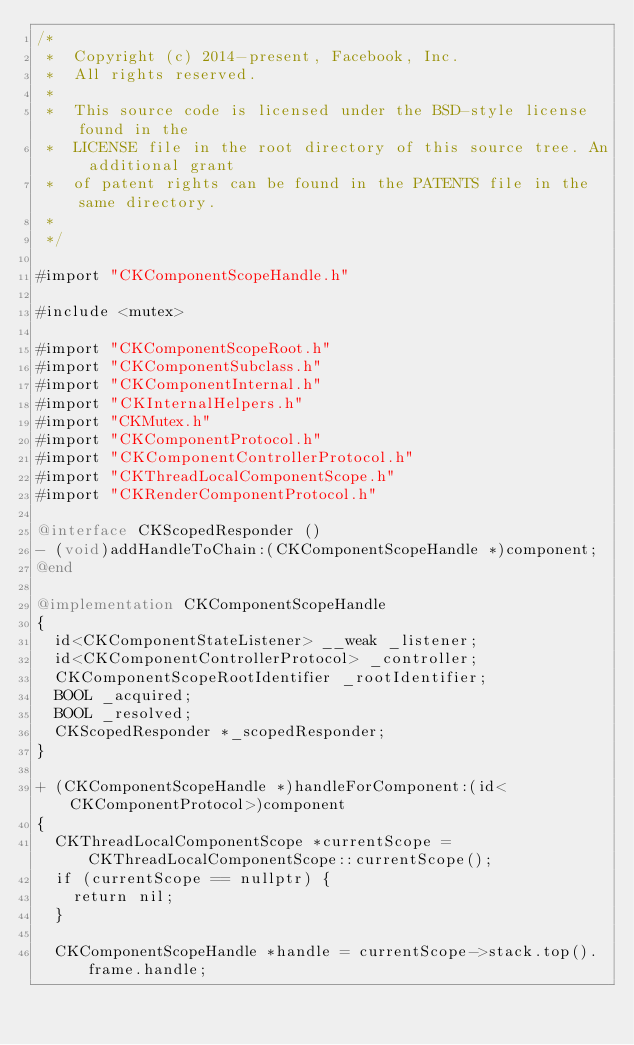Convert code to text. <code><loc_0><loc_0><loc_500><loc_500><_ObjectiveC_>/*
 *  Copyright (c) 2014-present, Facebook, Inc.
 *  All rights reserved.
 *
 *  This source code is licensed under the BSD-style license found in the
 *  LICENSE file in the root directory of this source tree. An additional grant
 *  of patent rights can be found in the PATENTS file in the same directory.
 *
 */

#import "CKComponentScopeHandle.h"

#include <mutex>

#import "CKComponentScopeRoot.h"
#import "CKComponentSubclass.h"
#import "CKComponentInternal.h"
#import "CKInternalHelpers.h"
#import "CKMutex.h"
#import "CKComponentProtocol.h"
#import "CKComponentControllerProtocol.h"
#import "CKThreadLocalComponentScope.h"
#import "CKRenderComponentProtocol.h"

@interface CKScopedResponder ()
- (void)addHandleToChain:(CKComponentScopeHandle *)component;
@end

@implementation CKComponentScopeHandle
{
  id<CKComponentStateListener> __weak _listener;
  id<CKComponentControllerProtocol> _controller;
  CKComponentScopeRootIdentifier _rootIdentifier;
  BOOL _acquired;
  BOOL _resolved;
  CKScopedResponder *_scopedResponder;
}

+ (CKComponentScopeHandle *)handleForComponent:(id<CKComponentProtocol>)component
{
  CKThreadLocalComponentScope *currentScope = CKThreadLocalComponentScope::currentScope();
  if (currentScope == nullptr) {
    return nil;
  }

  CKComponentScopeHandle *handle = currentScope->stack.top().frame.handle;</code> 